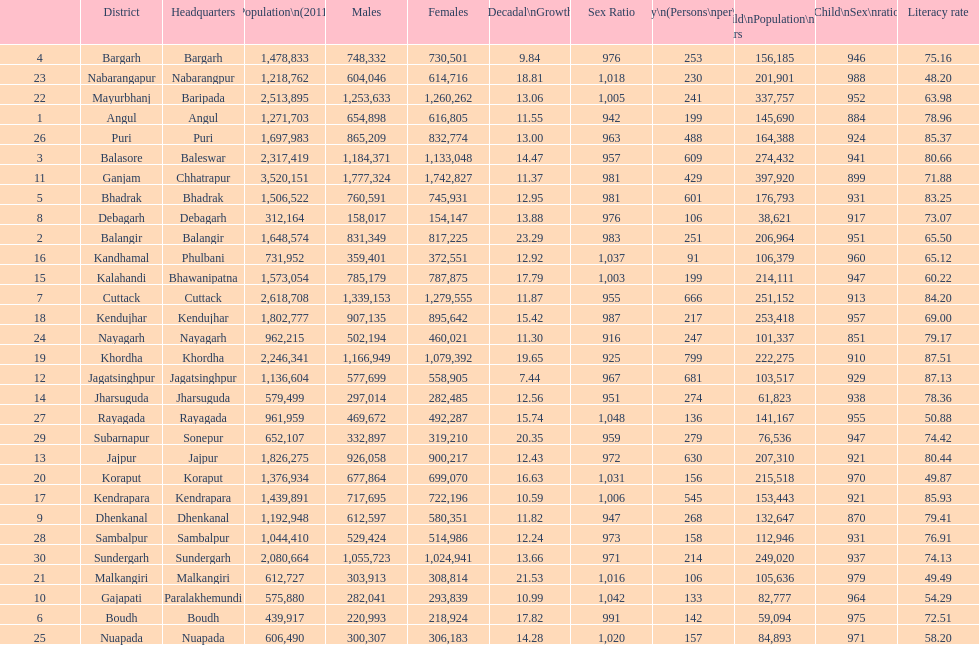Mention a district that had a population under 600,00 Boudh. 